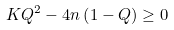Convert formula to latex. <formula><loc_0><loc_0><loc_500><loc_500>K Q ^ { 2 } - 4 n \left ( 1 - Q \right ) \geq 0</formula> 